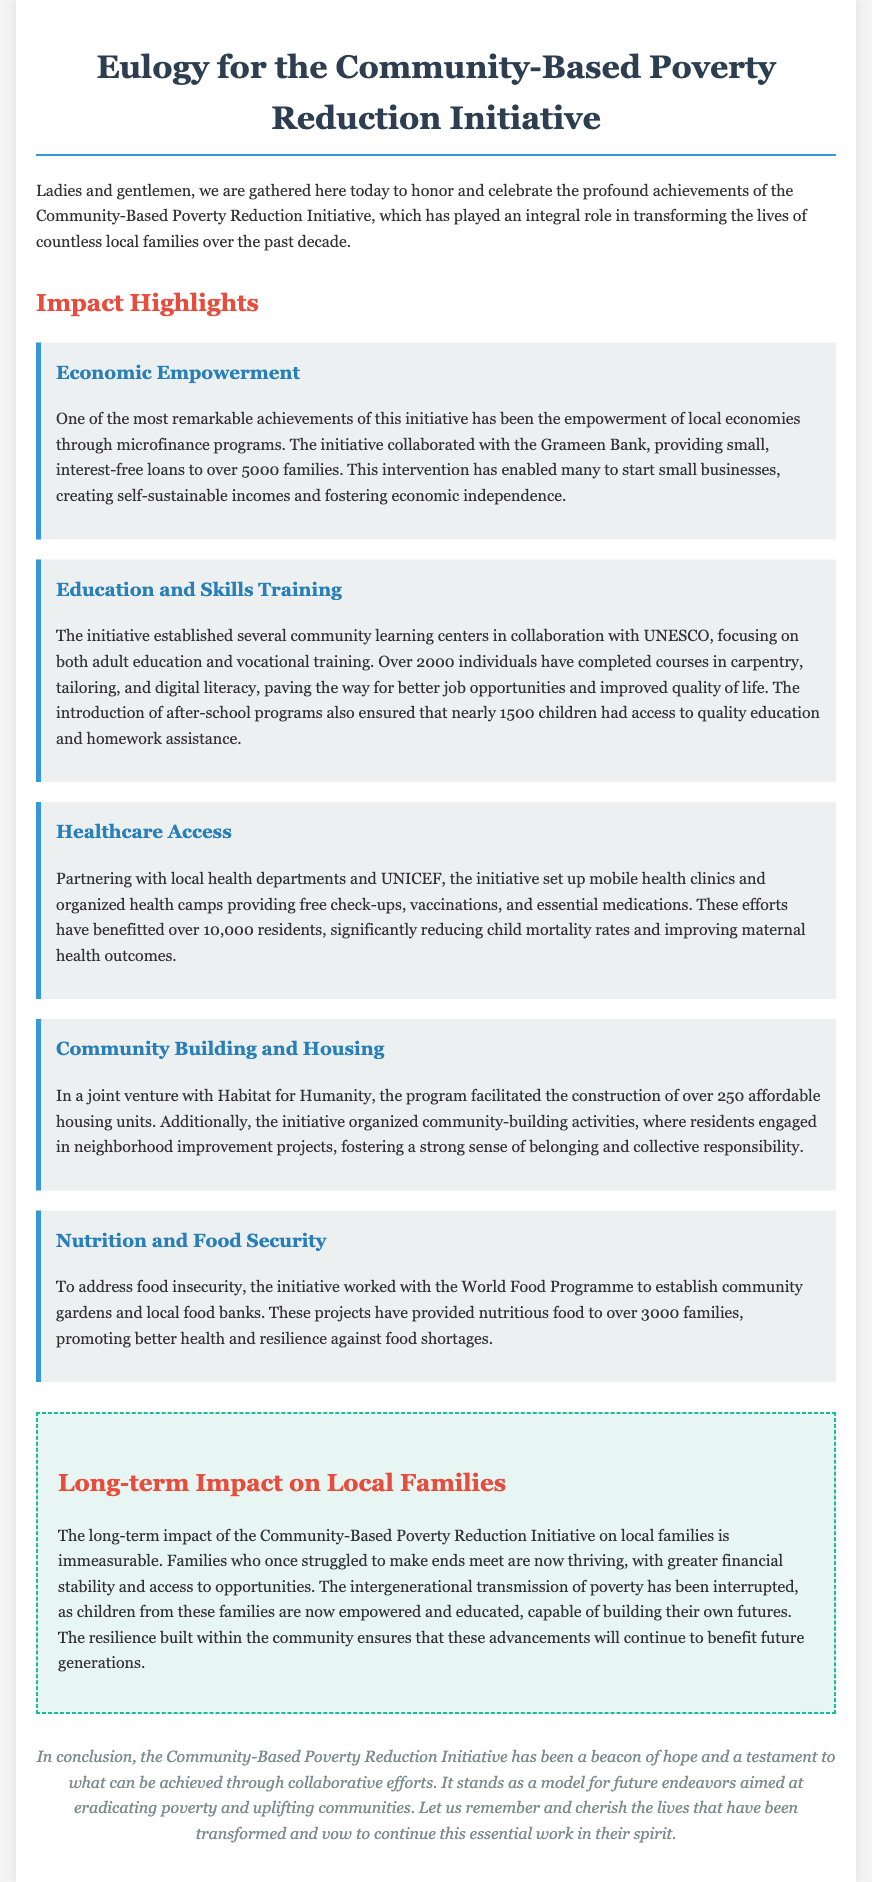what initiative is honored in the eulogy? The eulogy honors the Community-Based Poverty Reduction Initiative, as mentioned in the introduction.
Answer: Community-Based Poverty Reduction Initiative how many families benefited from microfinance programs? The document states that over 5000 families received small, interest-free loans.
Answer: 5000 families what types of vocational training were offered? The document lists courses in carpentry, tailoring, and digital literacy as part of the training programs.
Answer: carpentry, tailoring, and digital literacy how many individuals completed the community learning center courses? The eulogy mentions that over 2000 individuals completed various courses at the learning centers.
Answer: 2000 individuals which organization partnered to provide nutritious food to families? The document states that the initiative worked with the World Food Programme to establish community gardens and food banks.
Answer: World Food Programme what was one significant long-term impact on children from beneficiary families? The document highlights that children from these families are now empowered and educated, capable of building their own futures.
Answer: empowered and educated how many affordable housing units were constructed through the initiative? The document specifies that over 250 affordable housing units were constructed as part of the initiative.
Answer: 250 units what is a key factor that ensured the continuity of benefits for future generations? The eulogy notes that the resilience built within the community ensures continued benefits for future generations.
Answer: resilience built within the community 